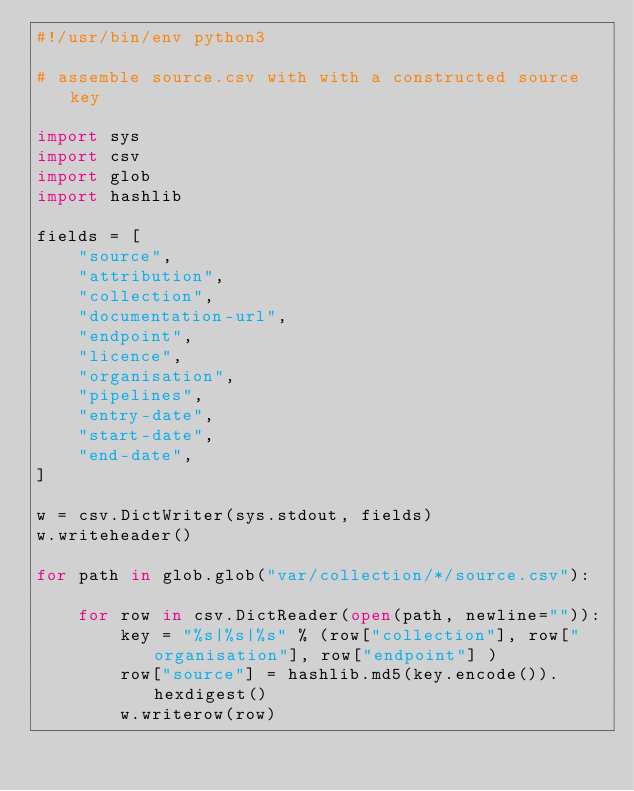<code> <loc_0><loc_0><loc_500><loc_500><_Python_>#!/usr/bin/env python3

# assemble source.csv with with a constructed source key

import sys
import csv
import glob
import hashlib

fields = [
    "source",
    "attribution",
    "collection",
    "documentation-url",
    "endpoint",
    "licence",
    "organisation",
    "pipelines",
    "entry-date",
    "start-date",
    "end-date",
]

w = csv.DictWriter(sys.stdout, fields)
w.writeheader()

for path in glob.glob("var/collection/*/source.csv"):

    for row in csv.DictReader(open(path, newline="")):
        key = "%s|%s|%s" % (row["collection"], row["organisation"], row["endpoint"] )
        row["source"] = hashlib.md5(key.encode()).hexdigest()
        w.writerow(row)
</code> 